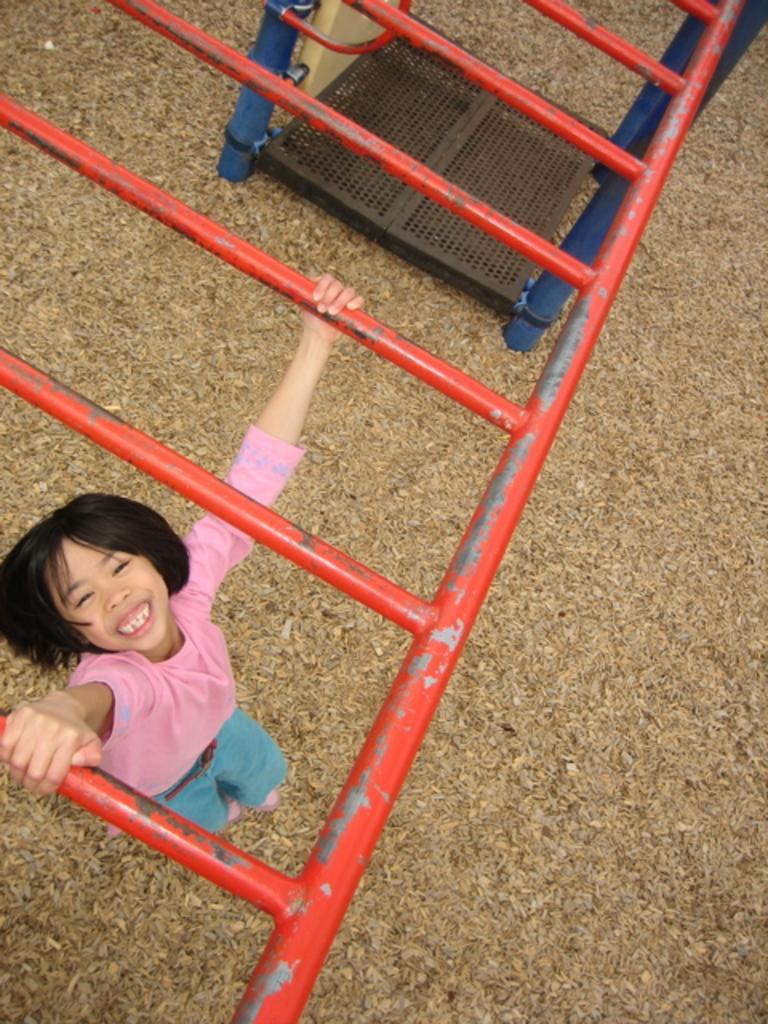Could you give a brief overview of what you see in this image? In this image we can see a girl hanging to the rods. In the background we can see a mesh. 